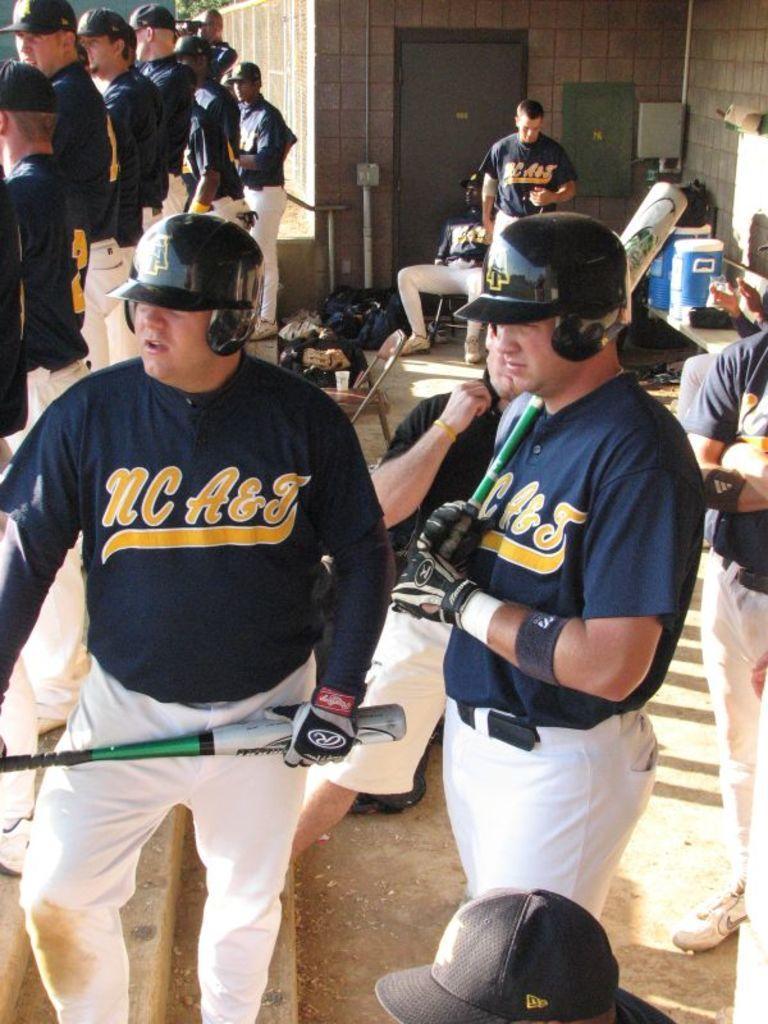In one or two sentences, can you explain what this image depicts? In this image I can see the group of people with navy blue and brown color dresses. I can see few people with helmets and caps. I can see few people are holding the baseball bats. In the background I can see few objects, door and the wall. 